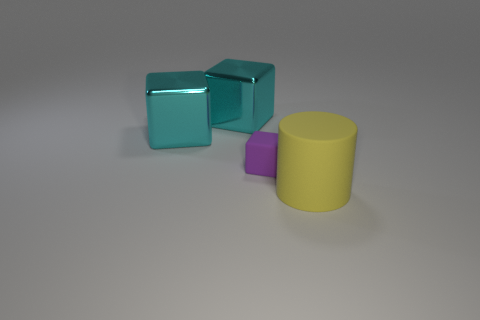Add 2 gray balls. How many objects exist? 6 Subtract all cylinders. How many objects are left? 3 Add 1 big metallic blocks. How many big metallic blocks exist? 3 Subtract 1 cyan cubes. How many objects are left? 3 Subtract all tiny cyan metal blocks. Subtract all cyan objects. How many objects are left? 2 Add 3 purple matte cubes. How many purple matte cubes are left? 4 